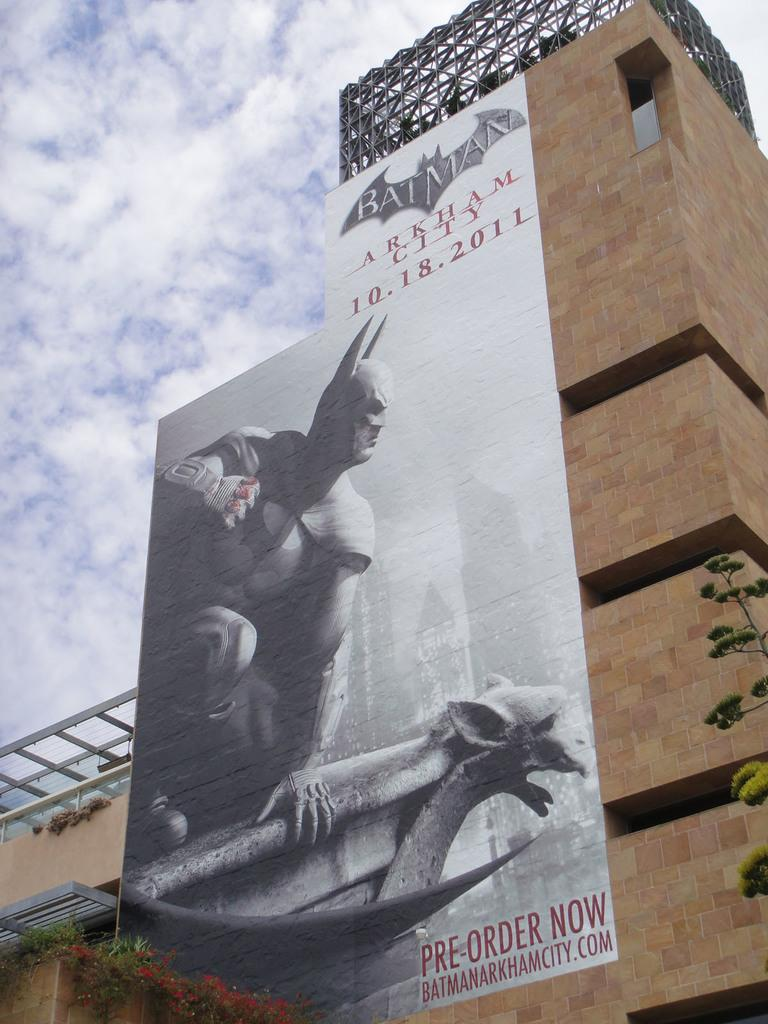<image>
Relay a brief, clear account of the picture shown. A huge billboard for Batman says that we can pre-order now. 